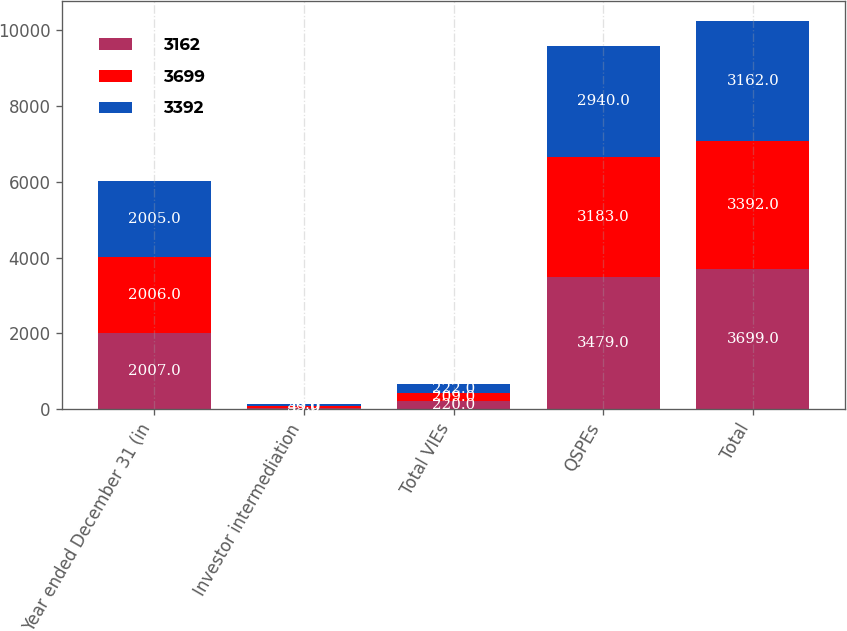<chart> <loc_0><loc_0><loc_500><loc_500><stacked_bar_chart><ecel><fcel>Year ended December 31 (in<fcel>Investor intermediation<fcel>Total VIEs<fcel>QSPEs<fcel>Total<nl><fcel>3162<fcel>2007<fcel>33<fcel>220<fcel>3479<fcel>3699<nl><fcel>3699<fcel>2006<fcel>49<fcel>209<fcel>3183<fcel>3392<nl><fcel>3392<fcel>2005<fcel>50<fcel>222<fcel>2940<fcel>3162<nl></chart> 